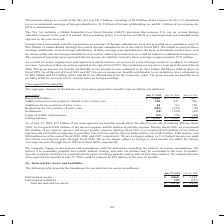According to Cisco Systems's financial document, How much net interest expense did the company recognize in fiscal year 2019? According to the financial document, $30 million. The relevant text states: "ate if realized. During fiscal 2019, we recognized $30 million of net interest expense and $6 million of penalty expense. During fiscal 2018, we recognized $10 mil..." Also, What was the company's total accrual for interest and penalties in fiscal 2018? According to the financial document, $180 million. The relevant text states: "crual for interest and penalties was $220 million, $180 million, and $186 million as of the end of fiscal 2019, 2018, and 2017, respectively. We are no longer subj..." Also, What were the Additions for tax positions of prior years in 2019? According to the financial document, 84 (in millions). The relevant text states: "336 Additions for tax positions of prior years . 84 84 180 Reductions for tax positions of prior years . (283) (129) (78) Settlements . (38) (124) (43)..." Also, can you calculate: What was the change in the Additions based on tax positions related to the current year between 2017 and 2018? Based on the calculation: 251-336, the result is -85 (in millions). This is based on the information: "x positions related to the current year . 185 251 336 Additions for tax positions of prior years . 84 84 180 Reductions for tax positions of prior years n tax positions related to the current year . 1..." The key data points involved are: 251, 336. Also, How many years did Additions for tax positions of prior years exceed $100 million? Based on the analysis, there are 1 instances (in millions). The counting process: 2017. Also, can you calculate: What was the percentage change in the Beginning balance between 2018 and 2019? To answer this question, I need to perform calculations using the financial data. The calculation is: (2,000-1,973)/1,973, which equals 1.37 (percentage). This is based on the information: "July 28, 2018 July 29, 2017 Beginning balance . $ 2,000 $ 1,973 $ 1,627 Additions based on tax positions related to the current year . 185 251 336 Addition 2018 July 29, 2017 Beginning balance . $ 2,0..." The key data points involved are: 1,973, 2,000. 